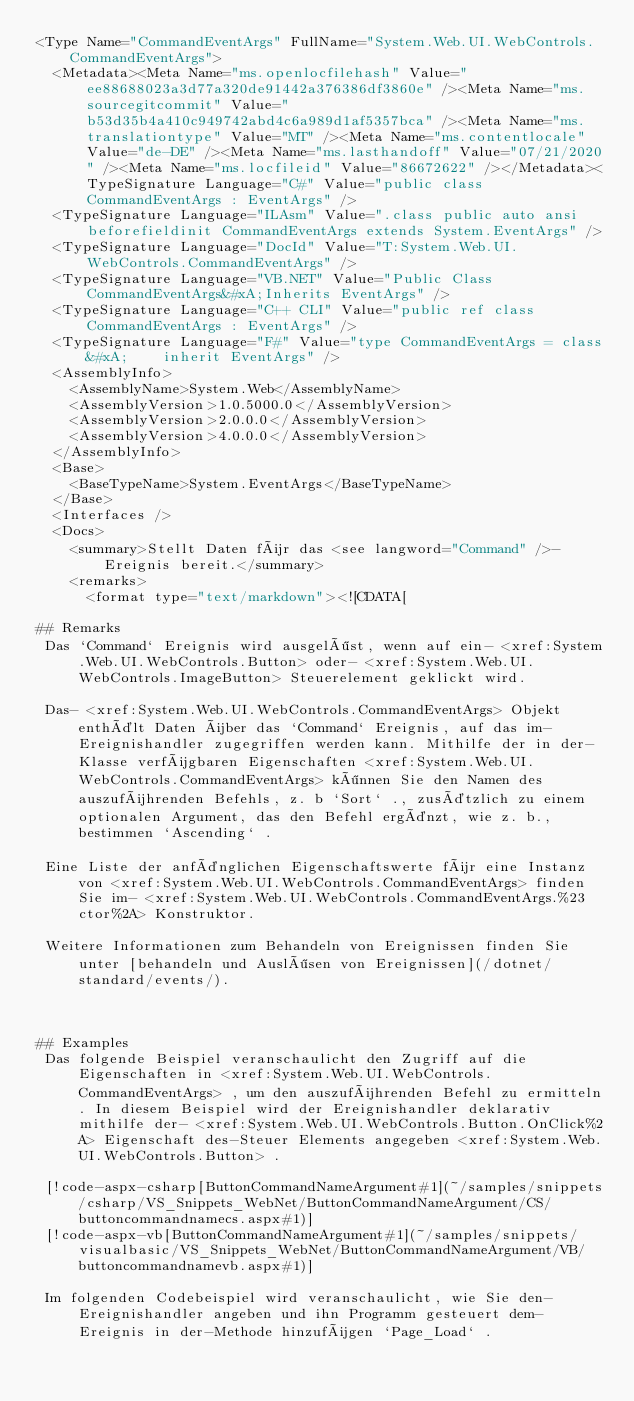<code> <loc_0><loc_0><loc_500><loc_500><_XML_><Type Name="CommandEventArgs" FullName="System.Web.UI.WebControls.CommandEventArgs">
  <Metadata><Meta Name="ms.openlocfilehash" Value="ee88688023a3d77a320de91442a376386df3860e" /><Meta Name="ms.sourcegitcommit" Value="b53d35b4a410c949742abd4c6a989d1af5357bca" /><Meta Name="ms.translationtype" Value="MT" /><Meta Name="ms.contentlocale" Value="de-DE" /><Meta Name="ms.lasthandoff" Value="07/21/2020" /><Meta Name="ms.locfileid" Value="86672622" /></Metadata><TypeSignature Language="C#" Value="public class CommandEventArgs : EventArgs" />
  <TypeSignature Language="ILAsm" Value=".class public auto ansi beforefieldinit CommandEventArgs extends System.EventArgs" />
  <TypeSignature Language="DocId" Value="T:System.Web.UI.WebControls.CommandEventArgs" />
  <TypeSignature Language="VB.NET" Value="Public Class CommandEventArgs&#xA;Inherits EventArgs" />
  <TypeSignature Language="C++ CLI" Value="public ref class CommandEventArgs : EventArgs" />
  <TypeSignature Language="F#" Value="type CommandEventArgs = class&#xA;    inherit EventArgs" />
  <AssemblyInfo>
    <AssemblyName>System.Web</AssemblyName>
    <AssemblyVersion>1.0.5000.0</AssemblyVersion>
    <AssemblyVersion>2.0.0.0</AssemblyVersion>
    <AssemblyVersion>4.0.0.0</AssemblyVersion>
  </AssemblyInfo>
  <Base>
    <BaseTypeName>System.EventArgs</BaseTypeName>
  </Base>
  <Interfaces />
  <Docs>
    <summary>Stellt Daten für das <see langword="Command" />-Ereignis bereit.</summary>
    <remarks>
      <format type="text/markdown"><![CDATA[  
  
## Remarks  
 Das `Command` Ereignis wird ausgelöst, wenn auf ein- <xref:System.Web.UI.WebControls.Button> oder- <xref:System.Web.UI.WebControls.ImageButton> Steuerelement geklickt wird.  
  
 Das- <xref:System.Web.UI.WebControls.CommandEventArgs> Objekt enthält Daten über das `Command` Ereignis, auf das im-Ereignishandler zugegriffen werden kann. Mithilfe der in der-Klasse verfügbaren Eigenschaften <xref:System.Web.UI.WebControls.CommandEventArgs> können Sie den Namen des auszuführenden Befehls, z. b `Sort` ., zusätzlich zu einem optionalen Argument, das den Befehl ergänzt, wie z. b., bestimmen `Ascending` .  
  
 Eine Liste der anfänglichen Eigenschaftswerte für eine Instanz von <xref:System.Web.UI.WebControls.CommandEventArgs> finden Sie im- <xref:System.Web.UI.WebControls.CommandEventArgs.%23ctor%2A> Konstruktor.  
  
 Weitere Informationen zum Behandeln von Ereignissen finden Sie unter [behandeln und Auslösen von Ereignissen](/dotnet/standard/events/).  
  
   
  
## Examples  
 Das folgende Beispiel veranschaulicht den Zugriff auf die Eigenschaften in <xref:System.Web.UI.WebControls.CommandEventArgs> , um den auszuführenden Befehl zu ermitteln. In diesem Beispiel wird der Ereignishandler deklarativ mithilfe der- <xref:System.Web.UI.WebControls.Button.OnClick%2A> Eigenschaft des-Steuer Elements angegeben <xref:System.Web.UI.WebControls.Button> .  
  
 [!code-aspx-csharp[ButtonCommandNameArgument#1](~/samples/snippets/csharp/VS_Snippets_WebNet/ButtonCommandNameArgument/CS/buttoncommandnamecs.aspx#1)]
 [!code-aspx-vb[ButtonCommandNameArgument#1](~/samples/snippets/visualbasic/VS_Snippets_WebNet/ButtonCommandNameArgument/VB/buttoncommandnamevb.aspx#1)]  
  
 Im folgenden Codebeispiel wird veranschaulicht, wie Sie den-Ereignishandler angeben und ihn Programm gesteuert dem-Ereignis in der-Methode hinzufügen `Page_Load` .  
  </code> 